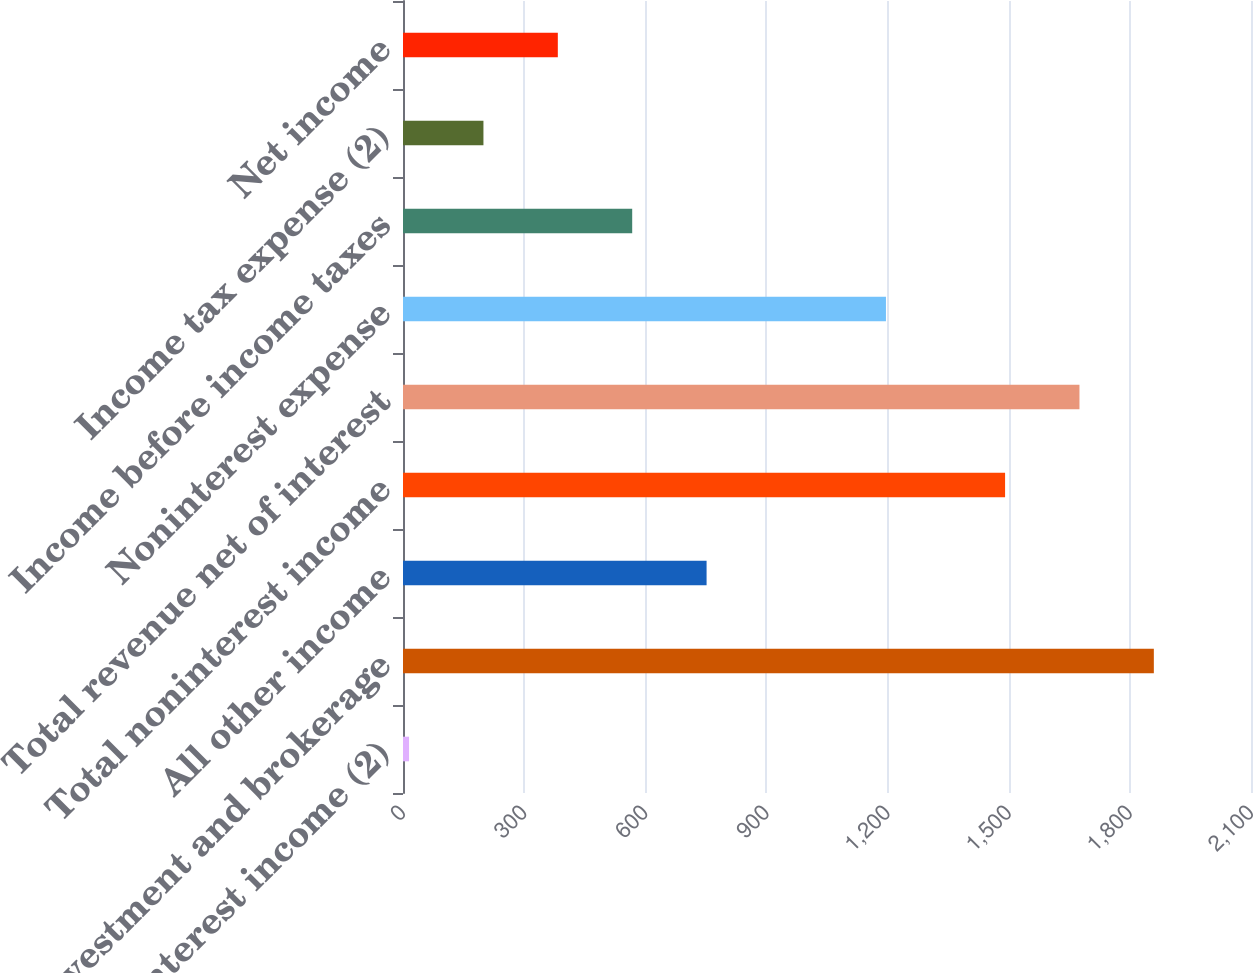Convert chart. <chart><loc_0><loc_0><loc_500><loc_500><bar_chart><fcel>Net interest income (2)<fcel>Investment and brokerage<fcel>All other income<fcel>Total noninterest income<fcel>Total revenue net of interest<fcel>Noninterest expense<fcel>Income before income taxes<fcel>Income tax expense (2)<fcel>Net income<nl><fcel>15<fcel>1859.4<fcel>751.8<fcel>1491<fcel>1675.2<fcel>1196<fcel>567.6<fcel>199.2<fcel>383.4<nl></chart> 